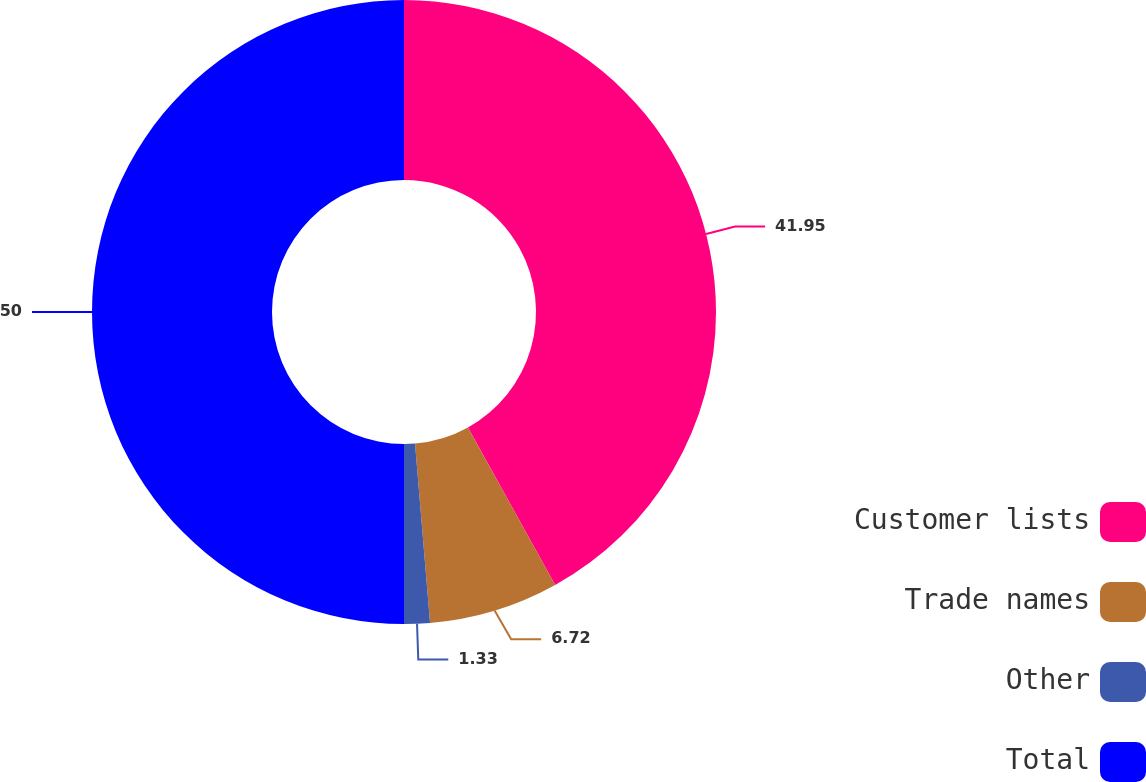Convert chart to OTSL. <chart><loc_0><loc_0><loc_500><loc_500><pie_chart><fcel>Customer lists<fcel>Trade names<fcel>Other<fcel>Total<nl><fcel>41.95%<fcel>6.72%<fcel>1.33%<fcel>50.0%<nl></chart> 